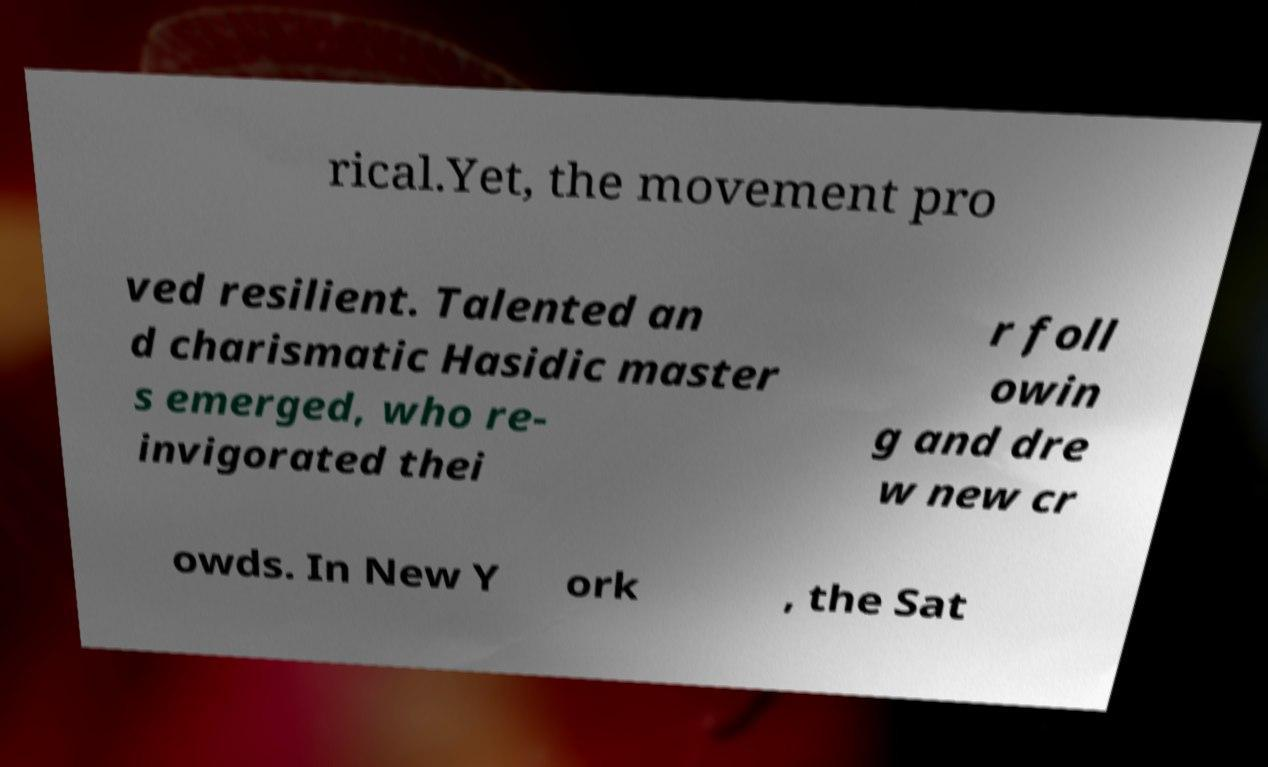Could you assist in decoding the text presented in this image and type it out clearly? rical.Yet, the movement pro ved resilient. Talented an d charismatic Hasidic master s emerged, who re- invigorated thei r foll owin g and dre w new cr owds. In New Y ork , the Sat 